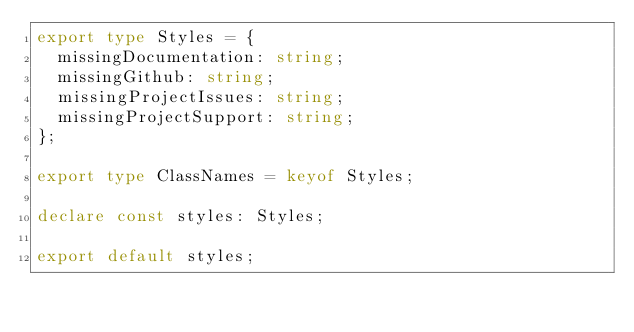Convert code to text. <code><loc_0><loc_0><loc_500><loc_500><_TypeScript_>export type Styles = {
  missingDocumentation: string;
  missingGithub: string;
  missingProjectIssues: string;
  missingProjectSupport: string;
};

export type ClassNames = keyof Styles;

declare const styles: Styles;

export default styles;
</code> 